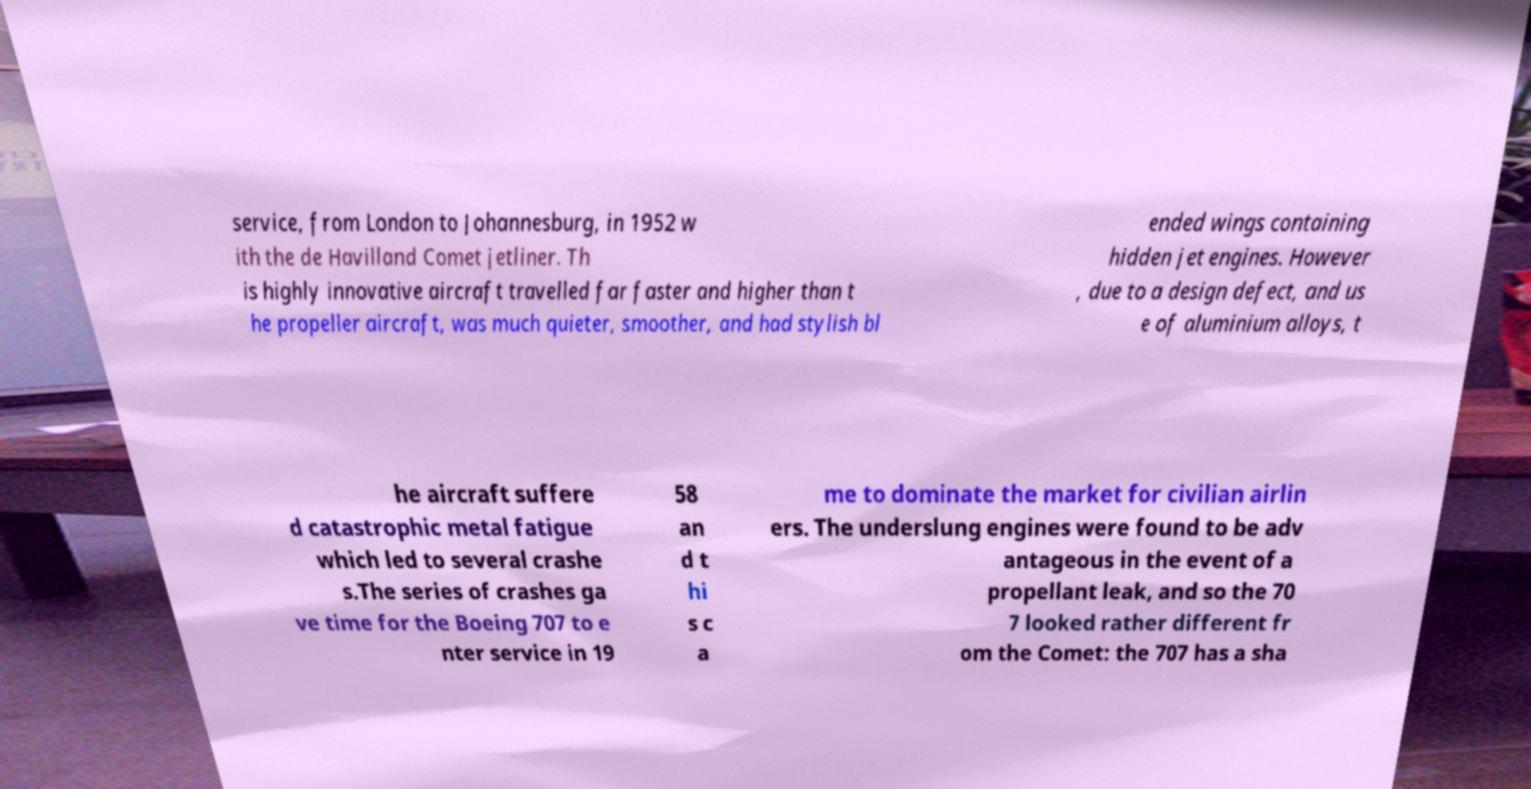Please identify and transcribe the text found in this image. service, from London to Johannesburg, in 1952 w ith the de Havilland Comet jetliner. Th is highly innovative aircraft travelled far faster and higher than t he propeller aircraft, was much quieter, smoother, and had stylish bl ended wings containing hidden jet engines. However , due to a design defect, and us e of aluminium alloys, t he aircraft suffere d catastrophic metal fatigue which led to several crashe s.The series of crashes ga ve time for the Boeing 707 to e nter service in 19 58 an d t hi s c a me to dominate the market for civilian airlin ers. The underslung engines were found to be adv antageous in the event of a propellant leak, and so the 70 7 looked rather different fr om the Comet: the 707 has a sha 